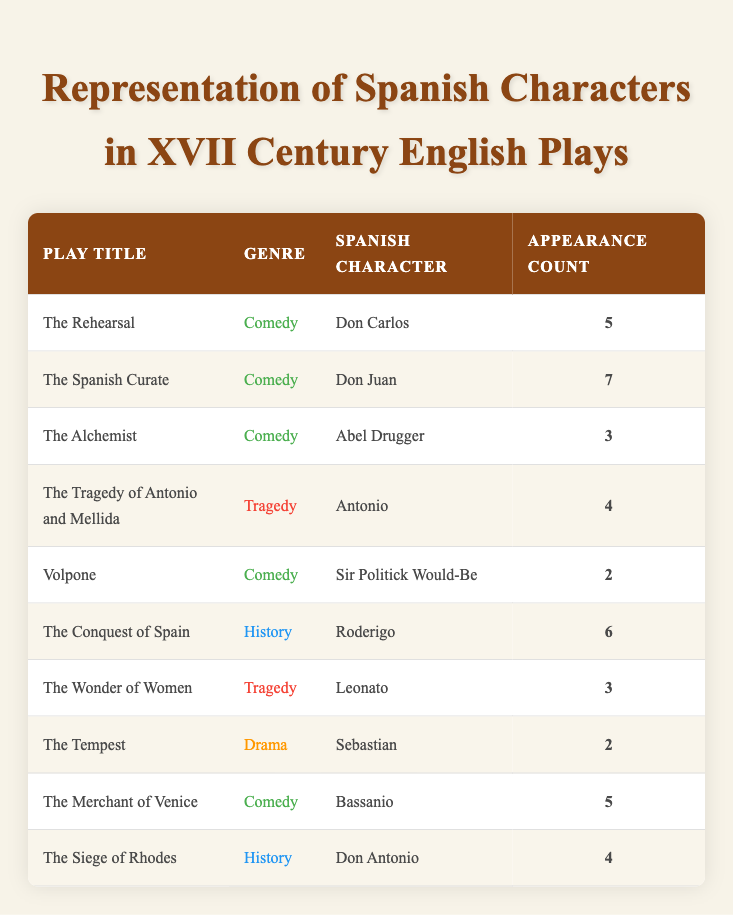What is the genre of the play "The Spanish Curate"? The table shows a row for "The Spanish Curate" with the genre listed under the corresponding column.
Answer: Comedy Which Spanish character appears the most in these plays? By examining the appearance count for each Spanish character, "Don Juan" has the highest count of 7 appearances in "The Spanish Curate".
Answer: Don Juan How many appearances do Spanish characters have in total in Comedy plays? Summing the appearance counts for all Comedy plays: 5 (Don Carlos) + 7 (Don Juan) + 3 (Abel Drugger) + 2 (Sir Politick Would-Be) + 5 (Bassanio) = 22 total appearances.
Answer: 22 Is "The Tempest" a play categorized as Comedy? Looking at the genre listed for "The Tempest" in the table, it is categorized as Drama, not Comedy.
Answer: No Which genre has the character with the lowest number of appearances? "The Tempest" has Sebastian appearing 2 times, which is less than all characters in other genres. Further analysis of the appearance counts confirms this is the lowest.
Answer: Drama 